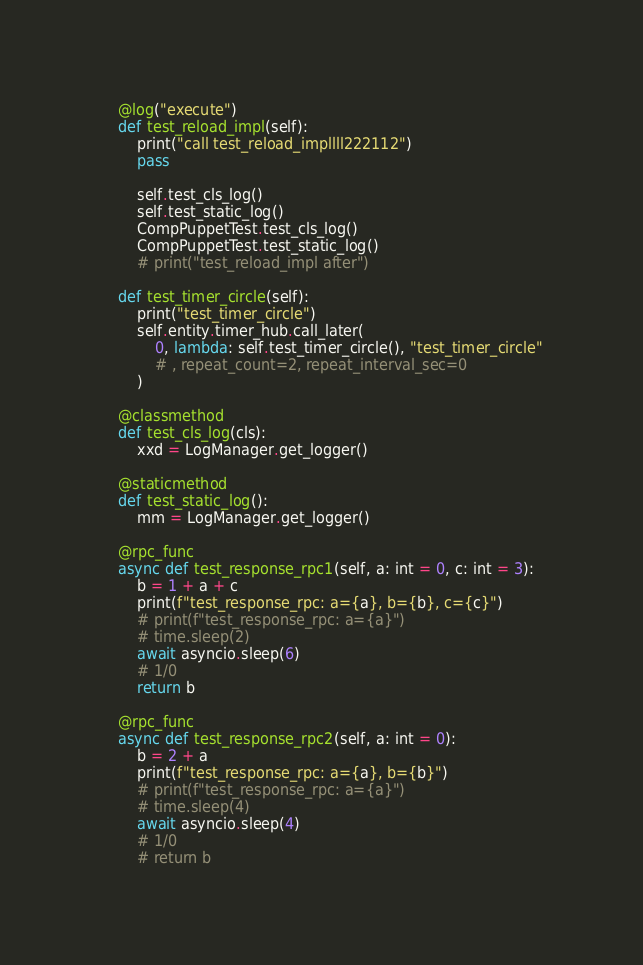<code> <loc_0><loc_0><loc_500><loc_500><_Python_>
    @log("execute")
    def test_reload_impl(self):
        print("call test_reload_impllll222112")
        pass

        self.test_cls_log()
        self.test_static_log()
        CompPuppetTest.test_cls_log()
        CompPuppetTest.test_static_log()
        # print("test_reload_impl after")

    def test_timer_circle(self):
        print("test_timer_circle")
        self.entity.timer_hub.call_later(
            0, lambda: self.test_timer_circle(), "test_timer_circle"
            # , repeat_count=2, repeat_interval_sec=0
        )

    @classmethod
    def test_cls_log(cls):
        xxd = LogManager.get_logger()

    @staticmethod
    def test_static_log():
        mm = LogManager.get_logger()

    @rpc_func
    async def test_response_rpc1(self, a: int = 0, c: int = 3):
        b = 1 + a + c
        print(f"test_response_rpc: a={a}, b={b}, c={c}")
        # print(f"test_response_rpc: a={a}")
        # time.sleep(2)
        await asyncio.sleep(6)
        # 1/0
        return b

    @rpc_func
    async def test_response_rpc2(self, a: int = 0):
        b = 2 + a
        print(f"test_response_rpc: a={a}, b={b}")
        # print(f"test_response_rpc: a={a}")
        # time.sleep(4)
        await asyncio.sleep(4)
        # 1/0
        # return b

</code> 